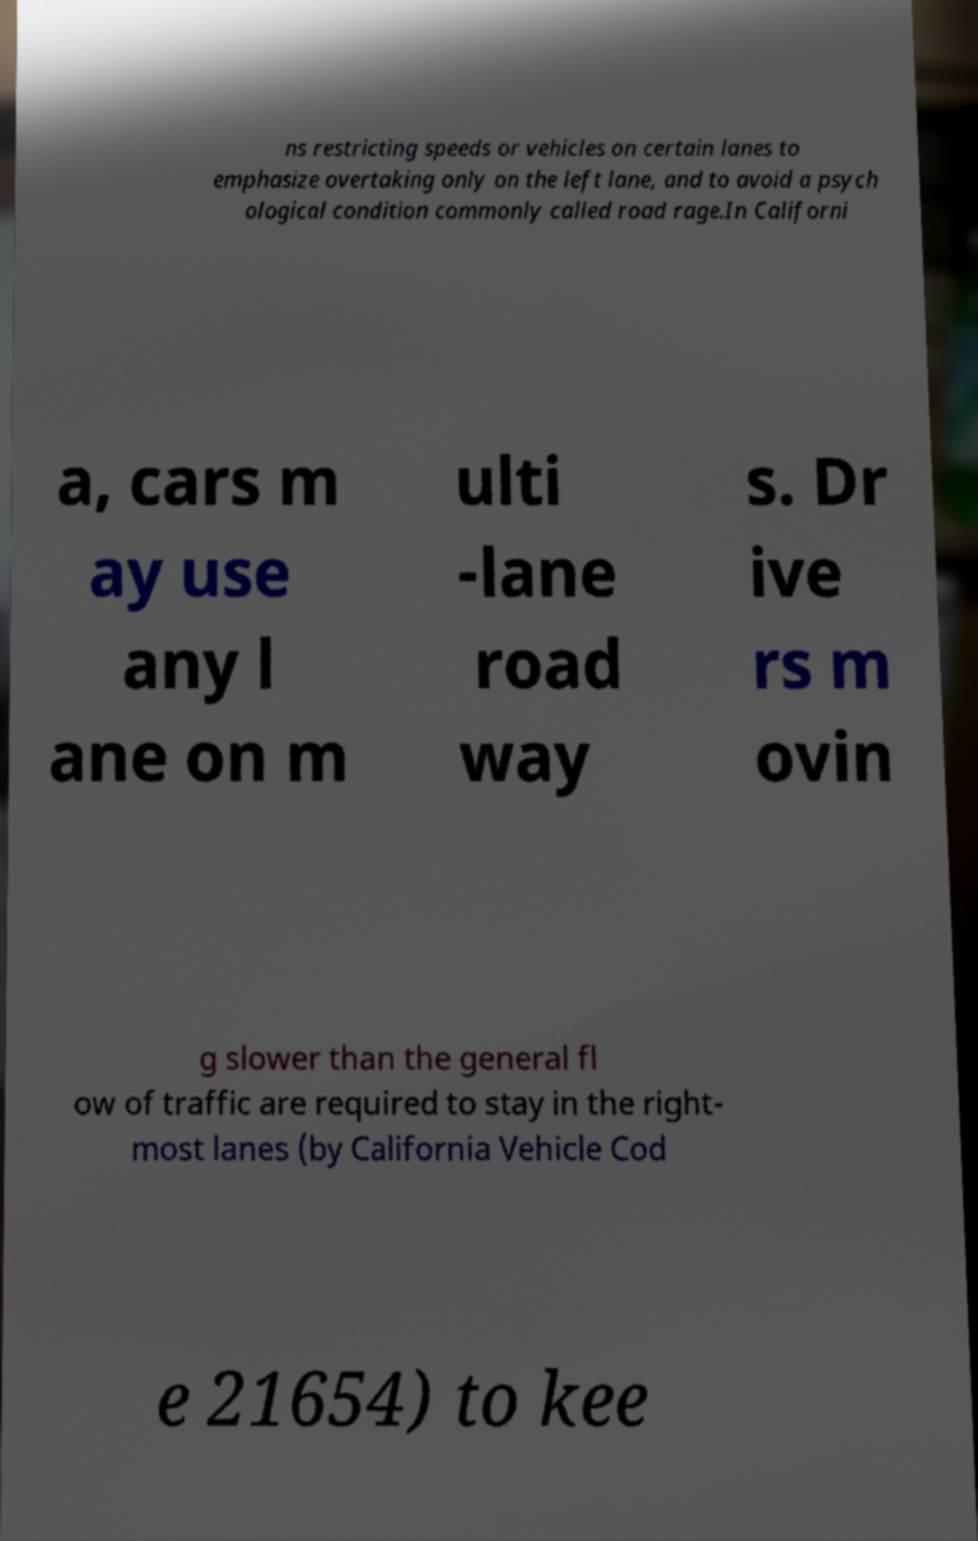Please read and relay the text visible in this image. What does it say? ns restricting speeds or vehicles on certain lanes to emphasize overtaking only on the left lane, and to avoid a psych ological condition commonly called road rage.In Californi a, cars m ay use any l ane on m ulti -lane road way s. Dr ive rs m ovin g slower than the general fl ow of traffic are required to stay in the right- most lanes (by California Vehicle Cod e 21654) to kee 